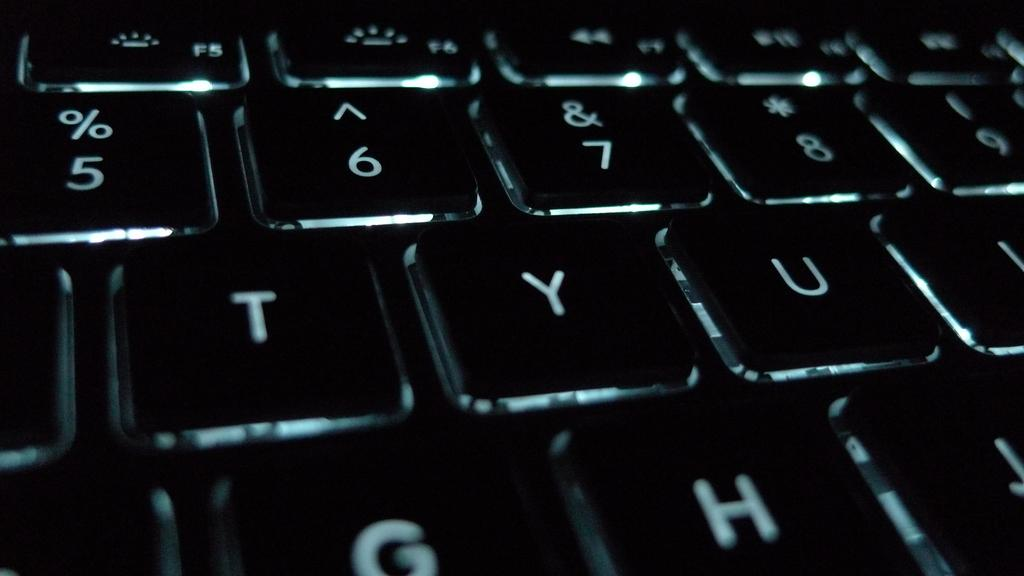<image>
Render a clear and concise summary of the photo. a close up of a black computer keyboard with keys % and Y 